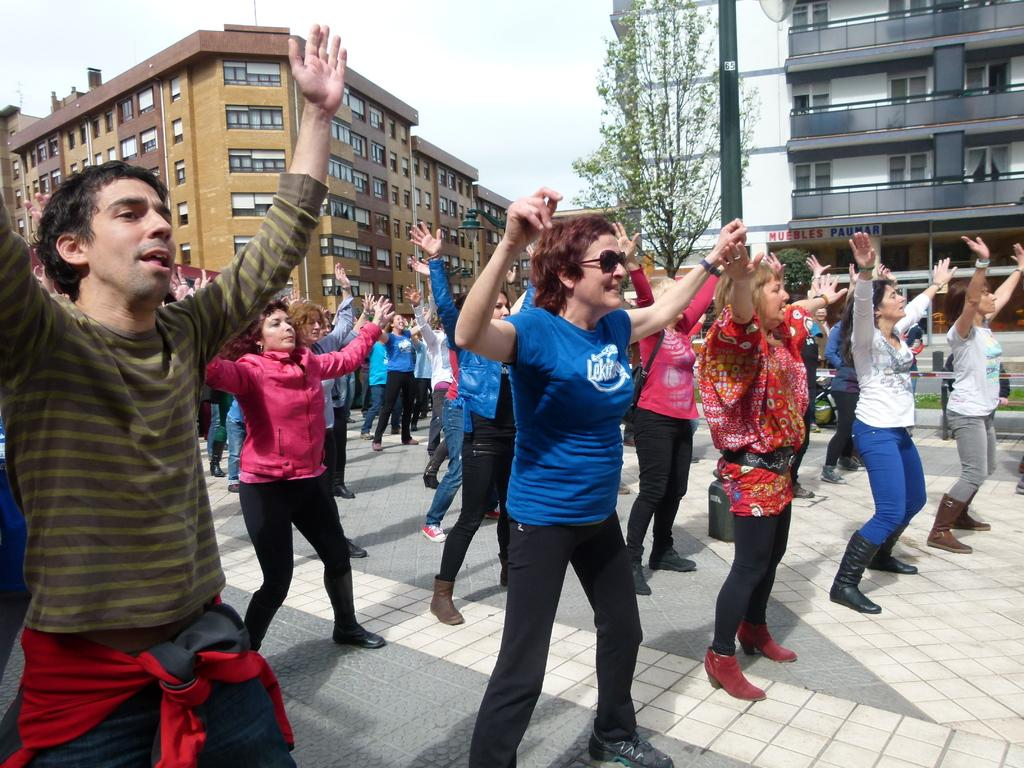What are the people in the image doing? The people in the image are dancing. Where are the people dancing? The people are dancing on the road. What can be seen in the background of the image? There are buildings and trees visible in the image. Can you see a zephyr blowing through the dancers' hair in the image? There is no mention of a zephyr or any wind blowing in the image, so we cannot confirm its presence. 